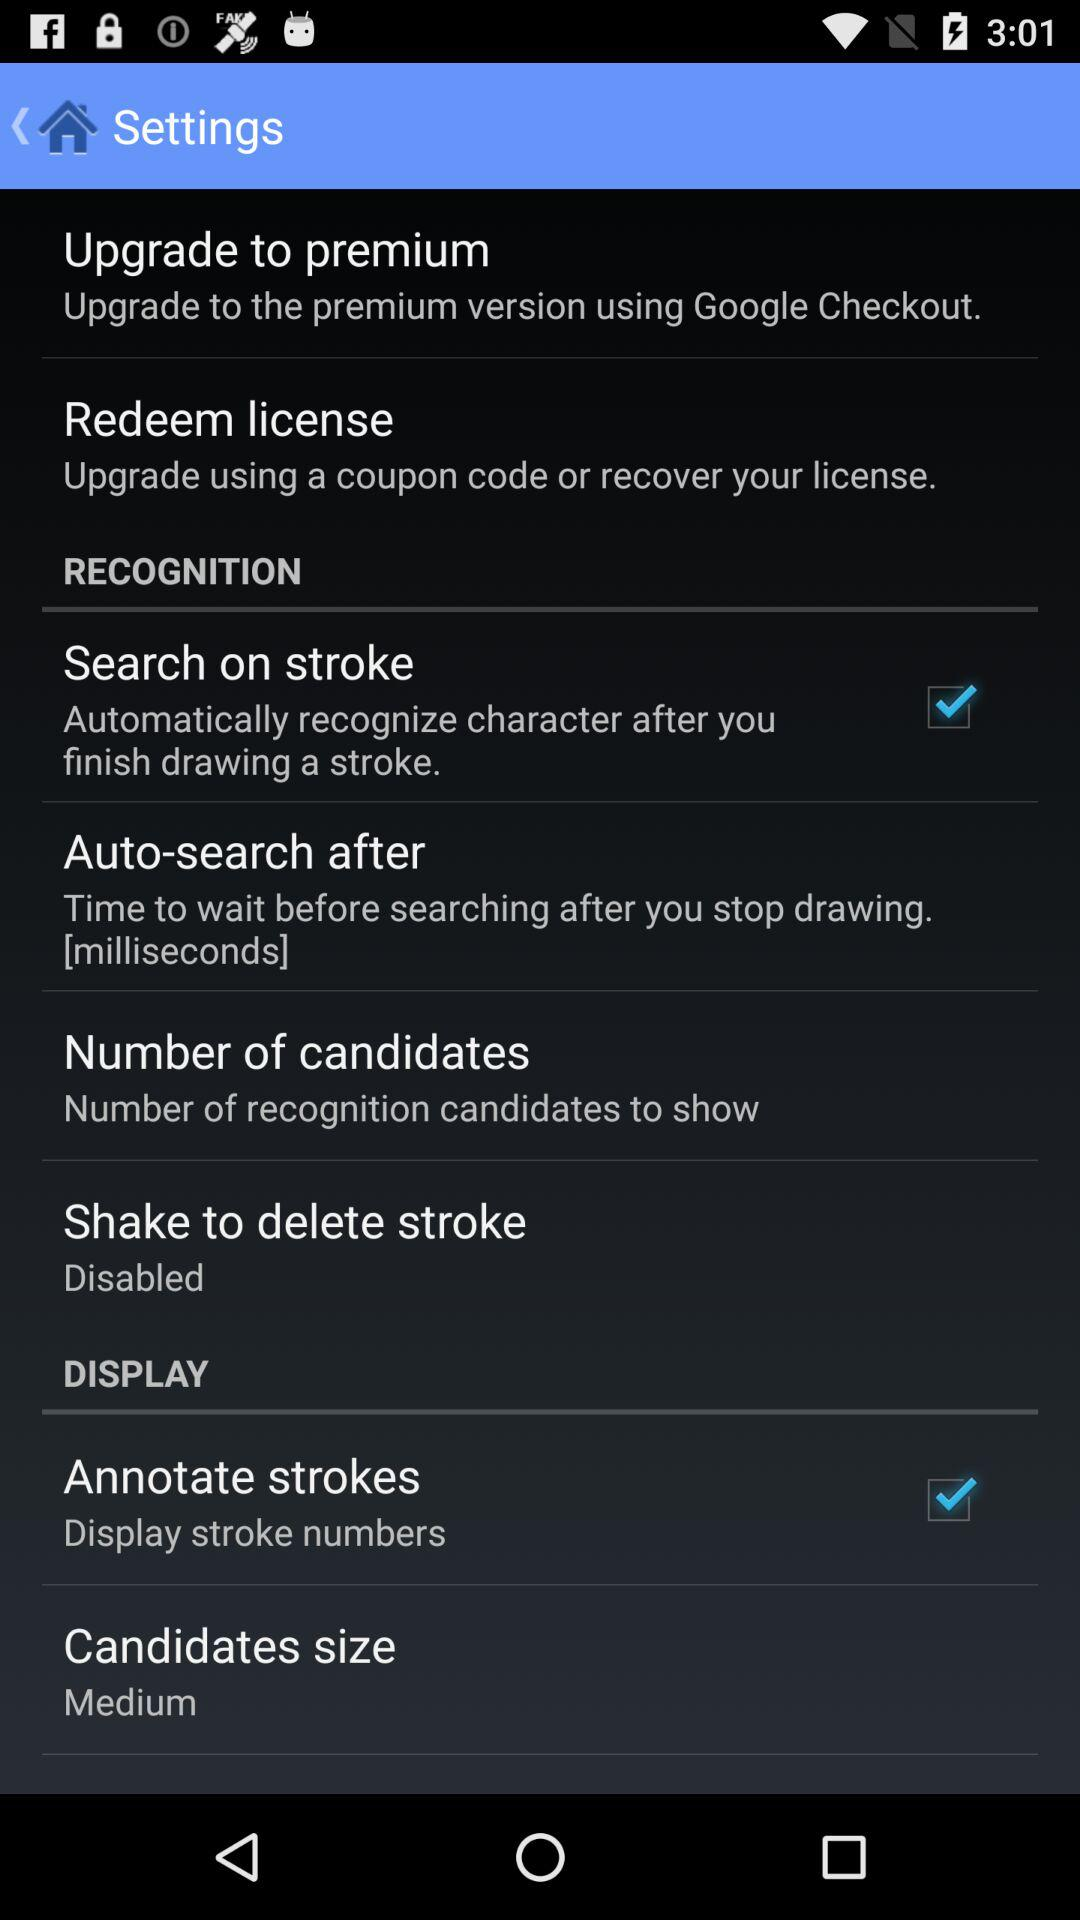What is the setting for "Candidates size"? The setting for "Candidates size" is "Medium". 